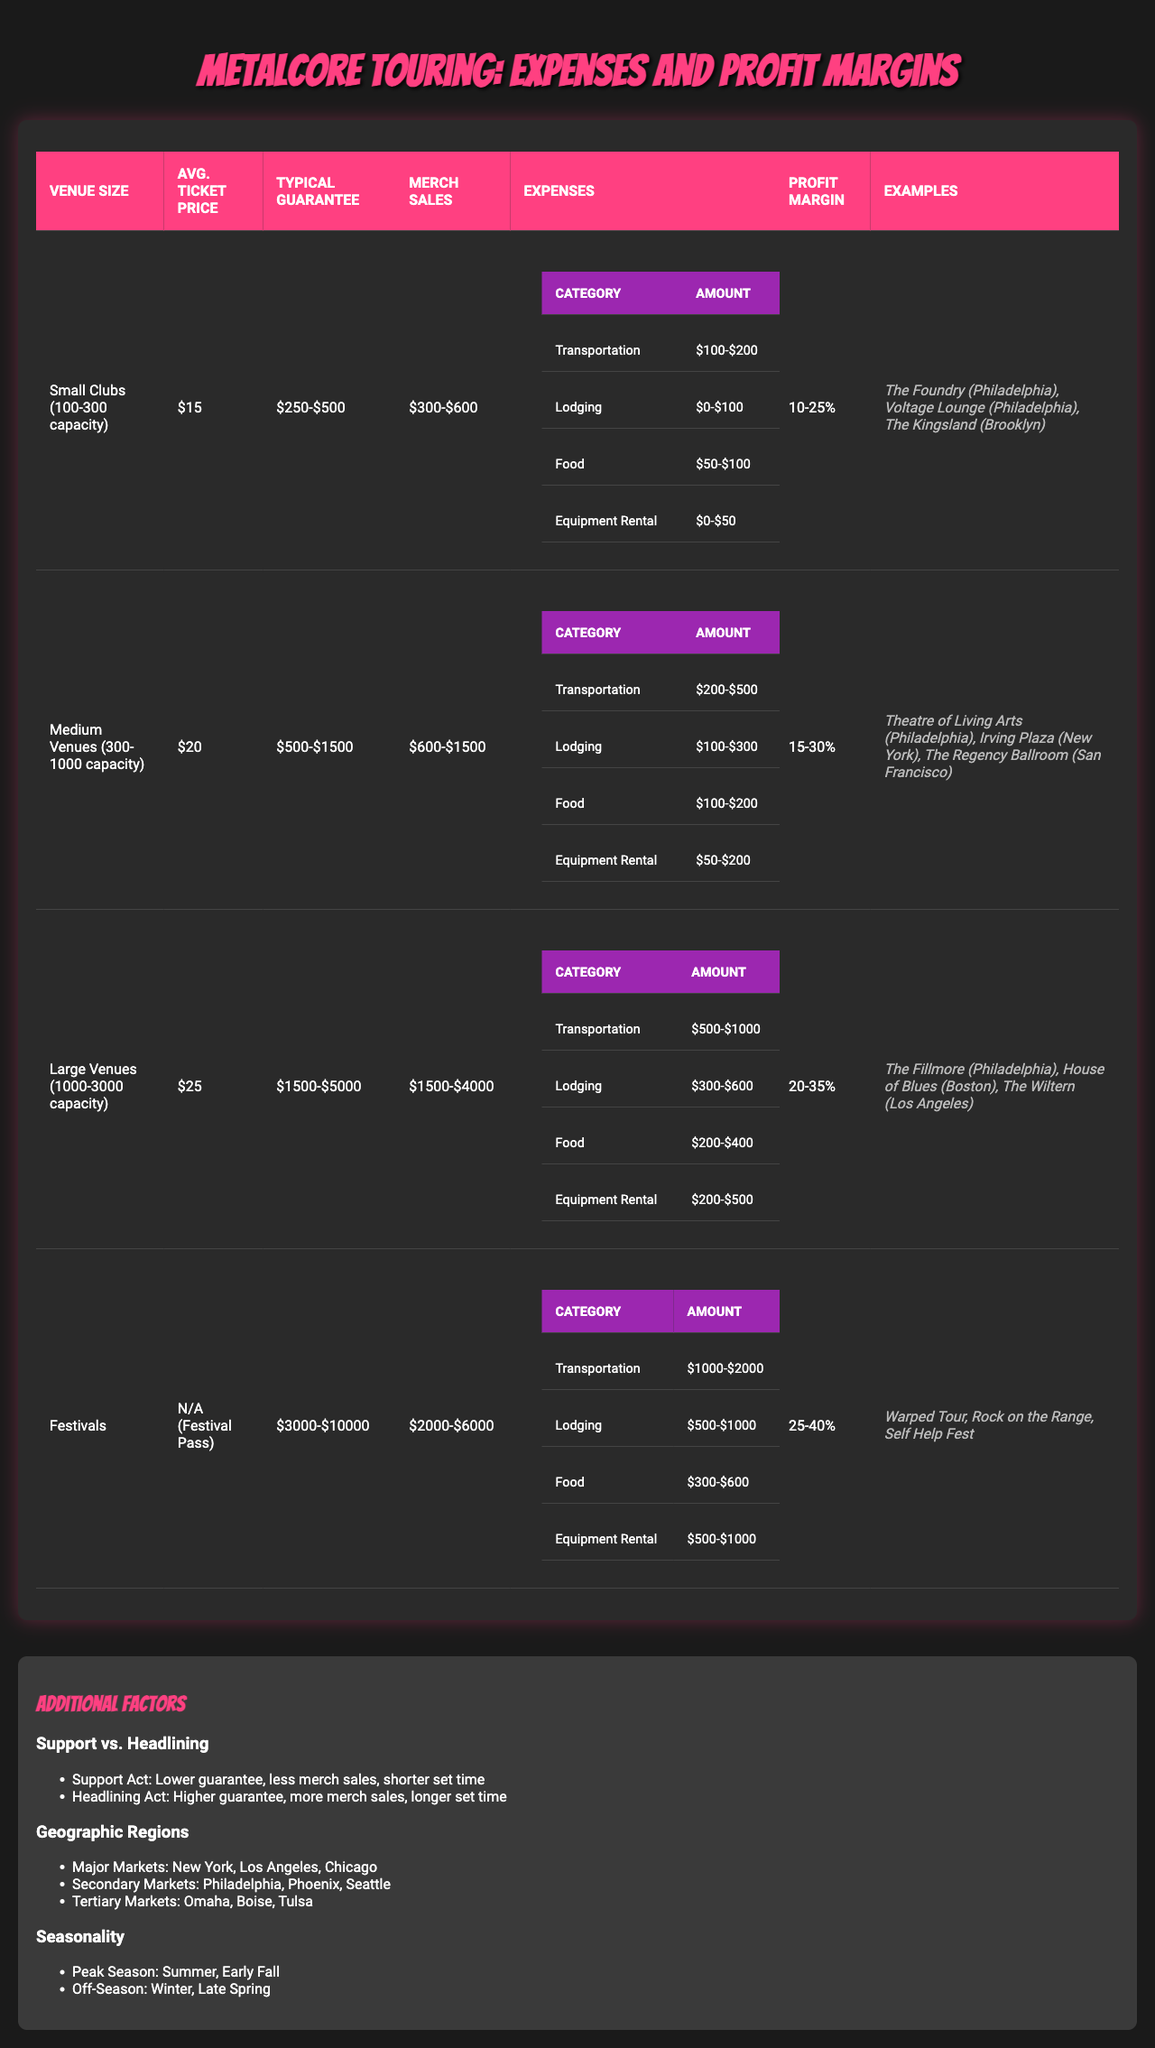What is the average ticket price for small clubs? The table indicates that the average ticket price for small clubs (100-300 capacity) is $15.
Answer: $15 What is the typical guarantee for large venues? According to the table, the typical guarantee for large venues (1000-3000 capacity) is between $1500 and $5000.
Answer: $1500-$5000 What is the profit margin range for medium venues? The data states that the profit margin for medium venues (300-1000 capacity) ranges from 15% to 30%.
Answer: 15-30% Which venue size has the highest average merchandise sales? From the table, large venues have the highest average merchandise sales of $1500 to $4000.
Answer: Large Venues What are the transportation expenses for festivals? The table lists transportation expenses for festivals as being between $1000 and $2000.
Answer: $1000-$2000 Is the average ticket price for festivals provided? The table states that the average ticket price for festivals is "N/A (Festival Pass)," which means it is not specified.
Answer: No Which venue size has the highest profit margin? Festivals have the highest profit margin, ranging from 25% to 40%, compared to the other venue sizes.
Answer: Festivals How much higher are the typical guarantees for festivals compared to small clubs? The typical guarantee for festivals ranges from $3000 to $10000, and for small clubs, it is between $250 and $500. Calculating the difference: 3000 - 500 = 2500, and 10000 - 250 = 9750 shows the typical guarantees for festivals are $2500 to $9750 higher.
Answer: $2500-$9750 What is the average profit margin for large venues compared to the smallest venue size? The profit margin for large venues is 20-35%, and for small clubs, it is 10-25%. The average profit margin for large venues is therefore 10% to 10% higher than for small clubs.
Answer: 10% to 10% higher Which city is an example of a major market? The table shows that major markets include New York, among others.
Answer: New York If a band is the headlining act in a medium venue, how would this impact their typical guarantee compared to being a support act? The typical guarantee for a headlining act is higher than for support acts. The table does not provide specific numbers for support acts, but it indicates that headliners have more sales and longer set times.
Answer: Higher guarantee 